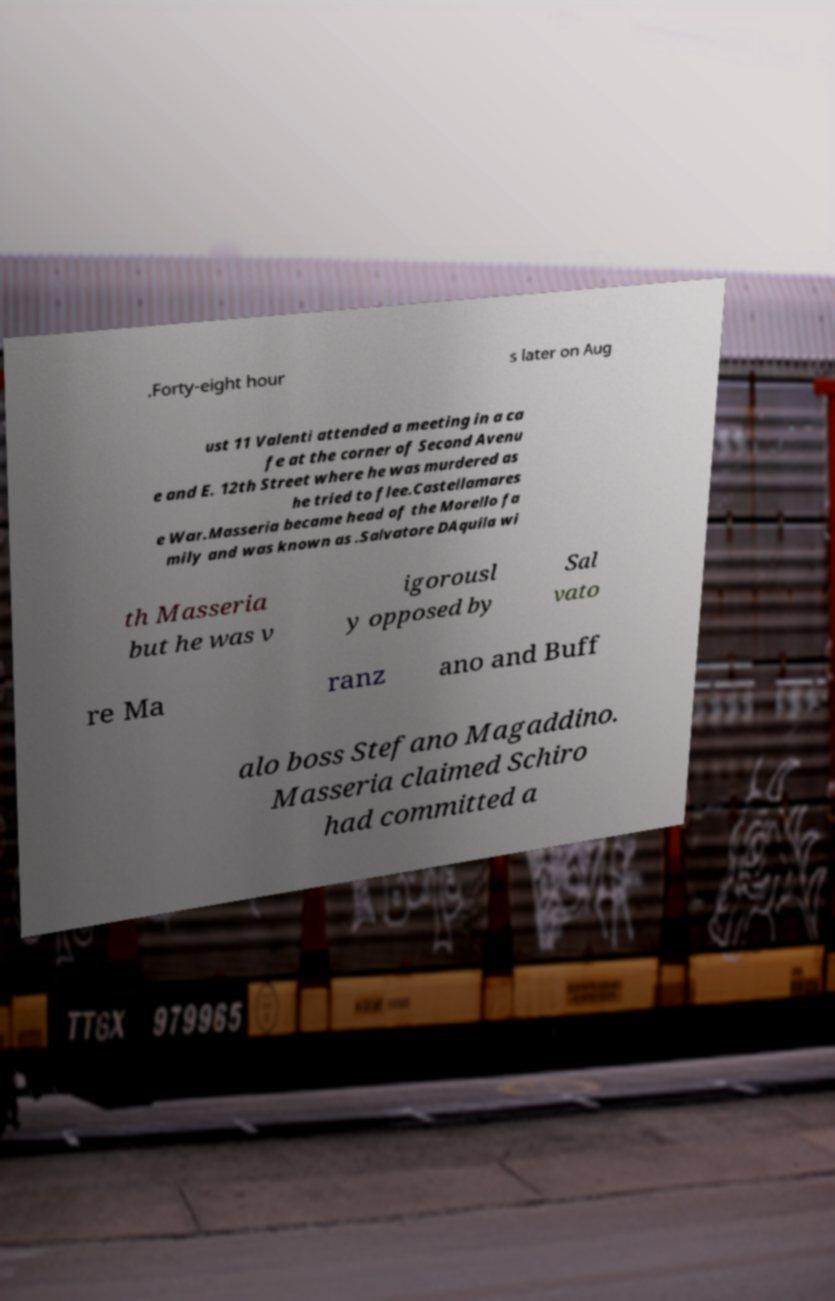What messages or text are displayed in this image? I need them in a readable, typed format. .Forty-eight hour s later on Aug ust 11 Valenti attended a meeting in a ca fe at the corner of Second Avenu e and E. 12th Street where he was murdered as he tried to flee.Castellamares e War.Masseria became head of the Morello fa mily and was known as .Salvatore DAquila wi th Masseria but he was v igorousl y opposed by Sal vato re Ma ranz ano and Buff alo boss Stefano Magaddino. Masseria claimed Schiro had committed a 